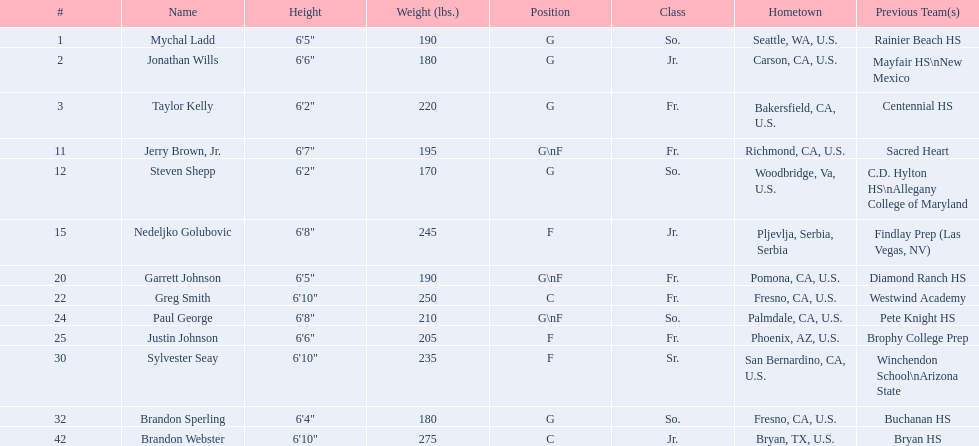Is the freshman (fr.) population higher than, equal to, or lower than the junior (jr.) population? Greater. 